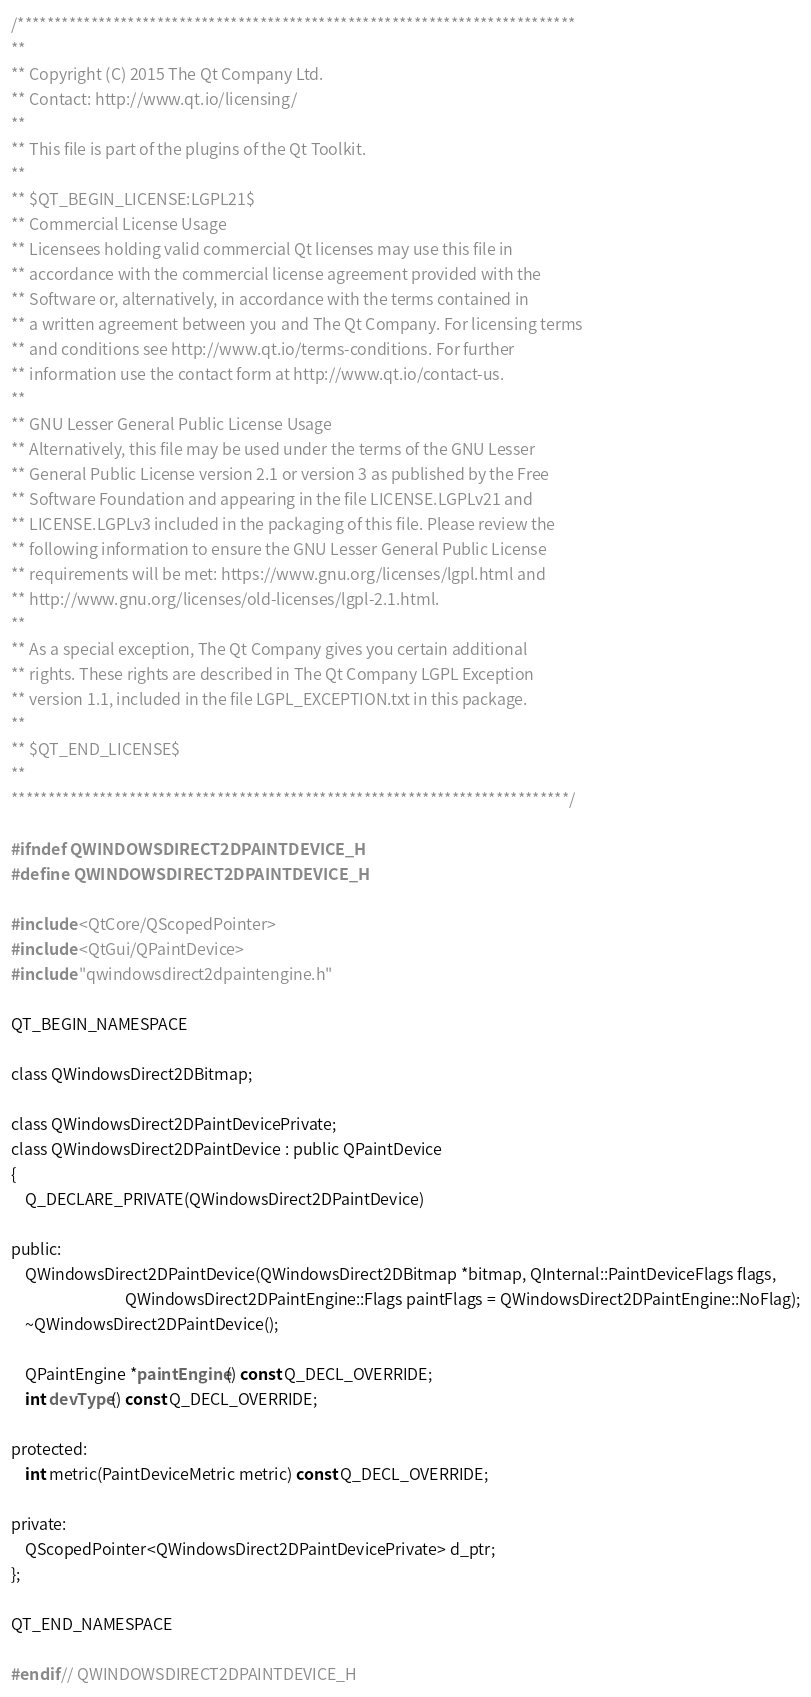Convert code to text. <code><loc_0><loc_0><loc_500><loc_500><_C_>/****************************************************************************
**
** Copyright (C) 2015 The Qt Company Ltd.
** Contact: http://www.qt.io/licensing/
**
** This file is part of the plugins of the Qt Toolkit.
**
** $QT_BEGIN_LICENSE:LGPL21$
** Commercial License Usage
** Licensees holding valid commercial Qt licenses may use this file in
** accordance with the commercial license agreement provided with the
** Software or, alternatively, in accordance with the terms contained in
** a written agreement between you and The Qt Company. For licensing terms
** and conditions see http://www.qt.io/terms-conditions. For further
** information use the contact form at http://www.qt.io/contact-us.
**
** GNU Lesser General Public License Usage
** Alternatively, this file may be used under the terms of the GNU Lesser
** General Public License version 2.1 or version 3 as published by the Free
** Software Foundation and appearing in the file LICENSE.LGPLv21 and
** LICENSE.LGPLv3 included in the packaging of this file. Please review the
** following information to ensure the GNU Lesser General Public License
** requirements will be met: https://www.gnu.org/licenses/lgpl.html and
** http://www.gnu.org/licenses/old-licenses/lgpl-2.1.html.
**
** As a special exception, The Qt Company gives you certain additional
** rights. These rights are described in The Qt Company LGPL Exception
** version 1.1, included in the file LGPL_EXCEPTION.txt in this package.
**
** $QT_END_LICENSE$
**
****************************************************************************/

#ifndef QWINDOWSDIRECT2DPAINTDEVICE_H
#define QWINDOWSDIRECT2DPAINTDEVICE_H

#include <QtCore/QScopedPointer>
#include <QtGui/QPaintDevice>
#include "qwindowsdirect2dpaintengine.h"

QT_BEGIN_NAMESPACE

class QWindowsDirect2DBitmap;

class QWindowsDirect2DPaintDevicePrivate;
class QWindowsDirect2DPaintDevice : public QPaintDevice
{
    Q_DECLARE_PRIVATE(QWindowsDirect2DPaintDevice)

public:
    QWindowsDirect2DPaintDevice(QWindowsDirect2DBitmap *bitmap, QInternal::PaintDeviceFlags flags,
                                QWindowsDirect2DPaintEngine::Flags paintFlags = QWindowsDirect2DPaintEngine::NoFlag);
    ~QWindowsDirect2DPaintDevice();

    QPaintEngine *paintEngine() const Q_DECL_OVERRIDE;
    int devType() const Q_DECL_OVERRIDE;

protected:
    int metric(PaintDeviceMetric metric) const Q_DECL_OVERRIDE;

private:
    QScopedPointer<QWindowsDirect2DPaintDevicePrivate> d_ptr;
};

QT_END_NAMESPACE

#endif // QWINDOWSDIRECT2DPAINTDEVICE_H
</code> 